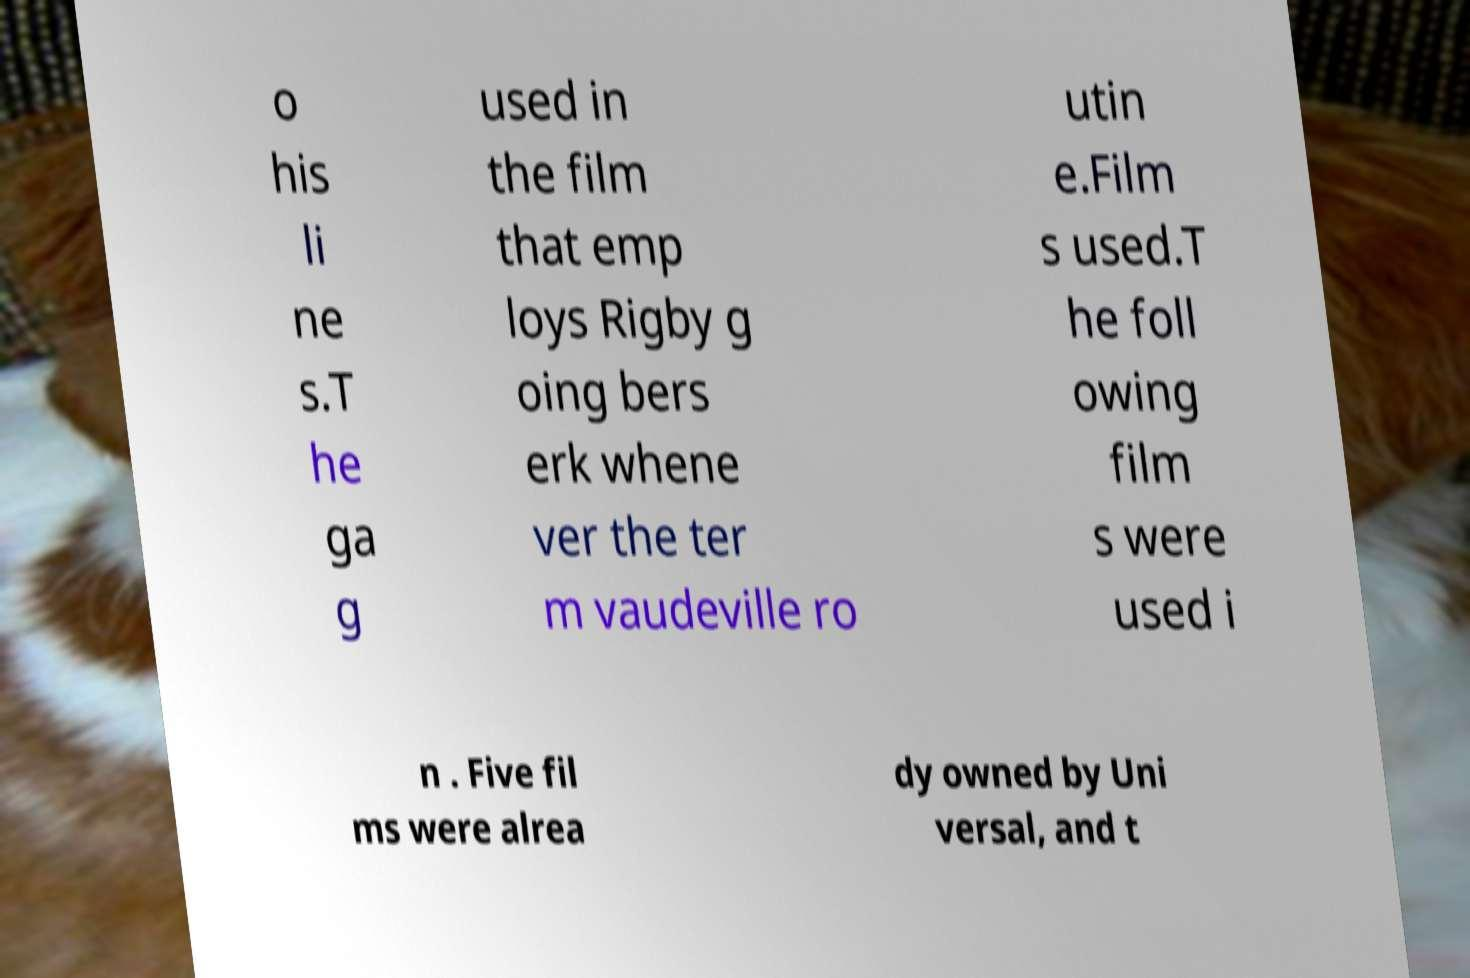Could you extract and type out the text from this image? o his li ne s.T he ga g used in the film that emp loys Rigby g oing bers erk whene ver the ter m vaudeville ro utin e.Film s used.T he foll owing film s were used i n . Five fil ms were alrea dy owned by Uni versal, and t 